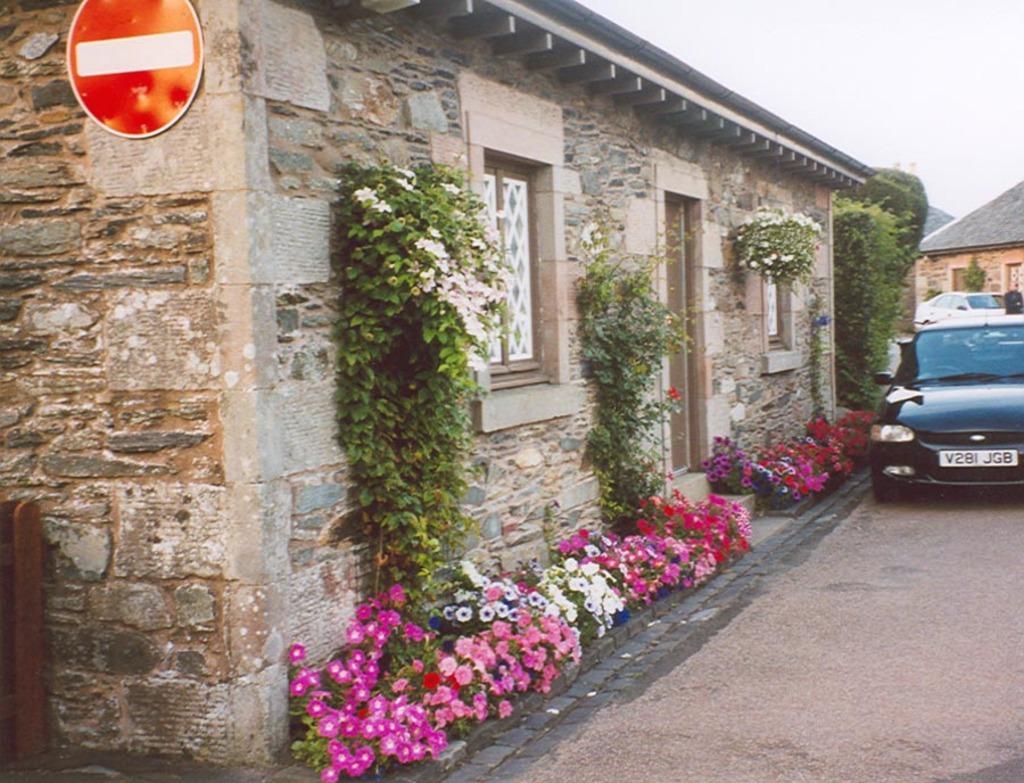Please provide a concise description of this image. In this image we can see some houses, there are some plants to which some flowers are grown and there is a car which is parked on the road and in the background of the image there is cloudy sky. 